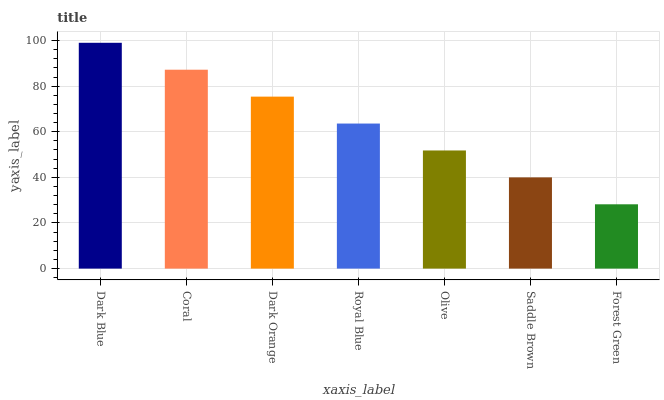Is Forest Green the minimum?
Answer yes or no. Yes. Is Dark Blue the maximum?
Answer yes or no. Yes. Is Coral the minimum?
Answer yes or no. No. Is Coral the maximum?
Answer yes or no. No. Is Dark Blue greater than Coral?
Answer yes or no. Yes. Is Coral less than Dark Blue?
Answer yes or no. Yes. Is Coral greater than Dark Blue?
Answer yes or no. No. Is Dark Blue less than Coral?
Answer yes or no. No. Is Royal Blue the high median?
Answer yes or no. Yes. Is Royal Blue the low median?
Answer yes or no. Yes. Is Olive the high median?
Answer yes or no. No. Is Saddle Brown the low median?
Answer yes or no. No. 